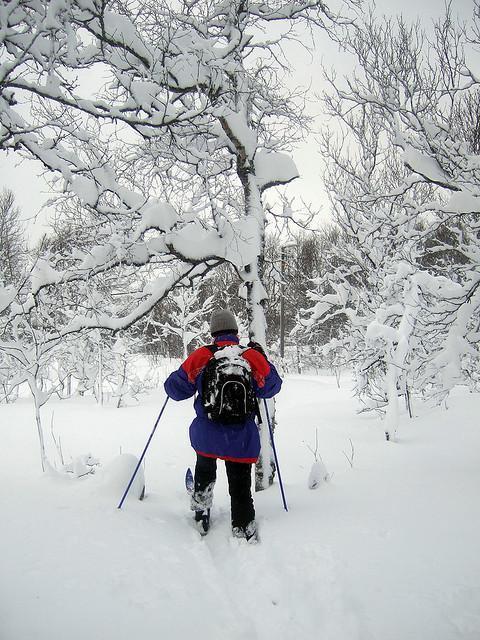How many colors of the French flag are missing from this photo?
Give a very brief answer. 0. How many people are there?
Give a very brief answer. 1. How many bears are in the chair?
Give a very brief answer. 0. 